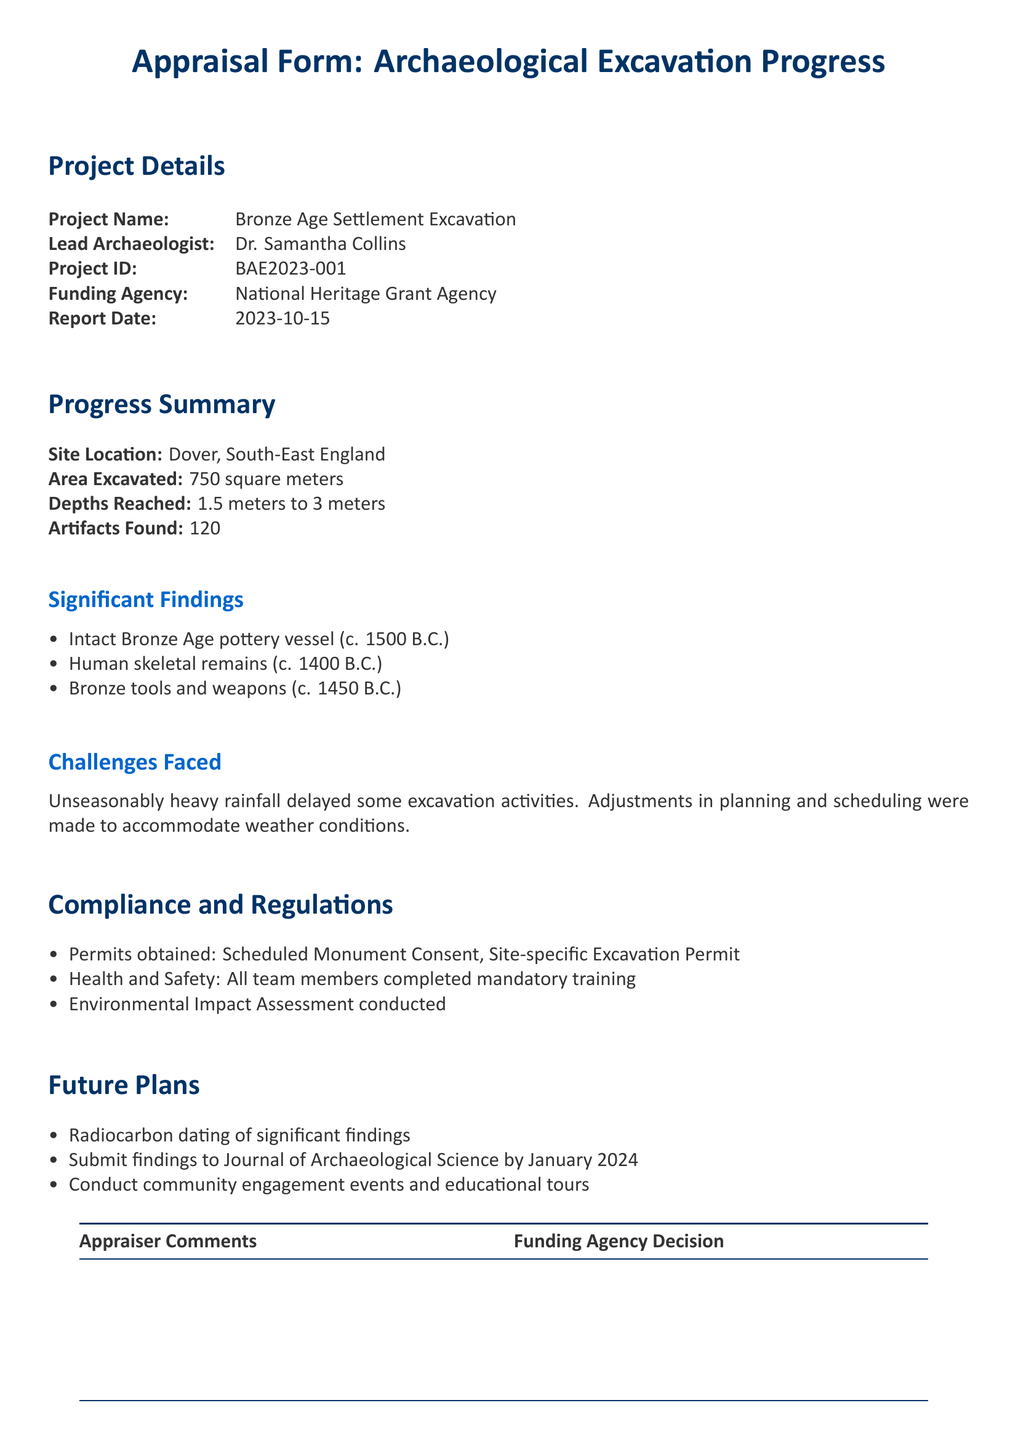What is the project name? The project name is clearly stated at the top of the document under Project Details.
Answer: Bronze Age Settlement Excavation Who is the lead archaeologist? The lead archaeologist is mentioned in the Project Details section of the document.
Answer: Dr. Samantha Collins What is the area excavated in square meters? The area excavated is specified in the Progress Summary.
Answer: 750 square meters How many artifacts were found? The number of artifacts found is provided in the Progress Summary section.
Answer: 120 What significant finding is dated to 1500 B.C.? The significant findings include a pottery vessel, which is noted in the Significant Findings section.
Answer: Intact Bronze Age pottery vessel What challenge did the excavation team face? The document details challenges encountered in the Challenges Faced section, which include environmental issues.
Answer: Heavy rainfall What type of assessment was conducted? The Compliance and Regulations section outlines conducted assessments related to environmental impact.
Answer: Environmental Impact Assessment What is the future plan for the findings? Future plans include submitting findings to an academic journal, as listed in the Future Plans section.
Answer: Submit findings to Journal of Archaeological Science by January 2024 How many significant findings are mentioned? The document lists the significant findings, which can be counted for this answer.
Answer: Three 